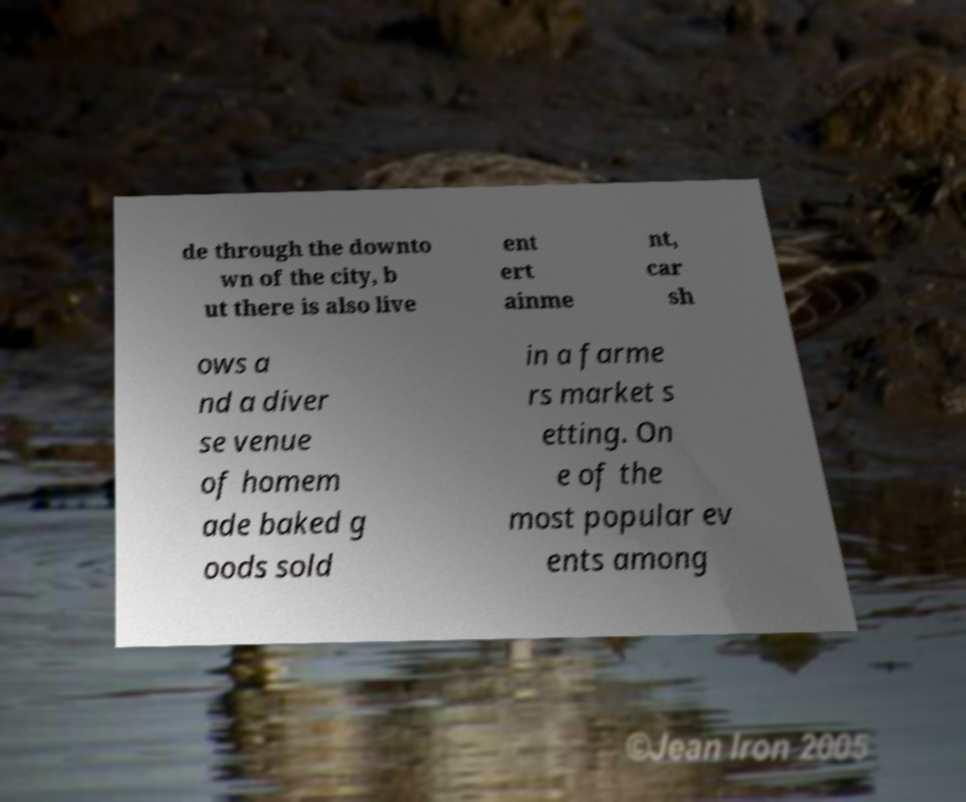What messages or text are displayed in this image? I need them in a readable, typed format. de through the downto wn of the city, b ut there is also live ent ert ainme nt, car sh ows a nd a diver se venue of homem ade baked g oods sold in a farme rs market s etting. On e of the most popular ev ents among 